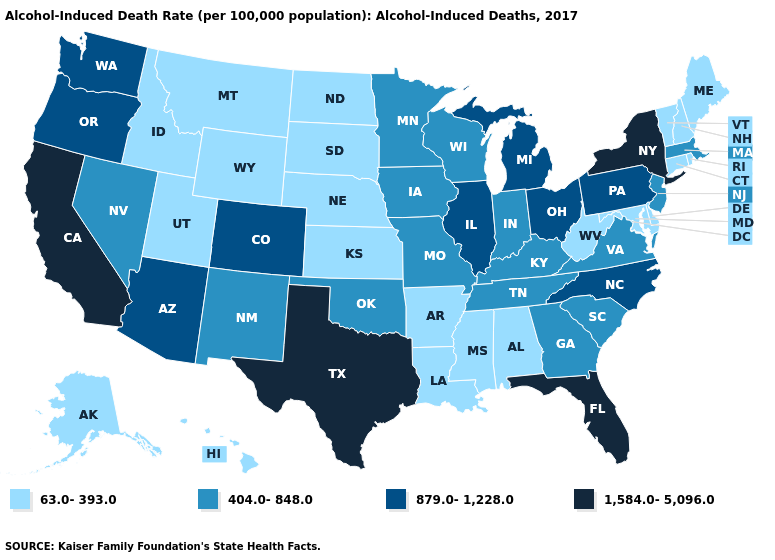Name the states that have a value in the range 1,584.0-5,096.0?
Keep it brief. California, Florida, New York, Texas. Which states hav the highest value in the MidWest?
Be succinct. Illinois, Michigan, Ohio. What is the value of Vermont?
Short answer required. 63.0-393.0. Which states have the lowest value in the West?
Be succinct. Alaska, Hawaii, Idaho, Montana, Utah, Wyoming. Does South Dakota have a lower value than Alaska?
Quick response, please. No. Does South Carolina have a higher value than Alabama?
Concise answer only. Yes. Name the states that have a value in the range 879.0-1,228.0?
Keep it brief. Arizona, Colorado, Illinois, Michigan, North Carolina, Ohio, Oregon, Pennsylvania, Washington. Does Iowa have the highest value in the USA?
Concise answer only. No. Which states hav the highest value in the Northeast?
Answer briefly. New York. What is the value of California?
Answer briefly. 1,584.0-5,096.0. Which states hav the highest value in the MidWest?
Answer briefly. Illinois, Michigan, Ohio. Among the states that border Pennsylvania , which have the lowest value?
Be succinct. Delaware, Maryland, West Virginia. Name the states that have a value in the range 1,584.0-5,096.0?
Answer briefly. California, Florida, New York, Texas. Which states have the highest value in the USA?
Quick response, please. California, Florida, New York, Texas. 